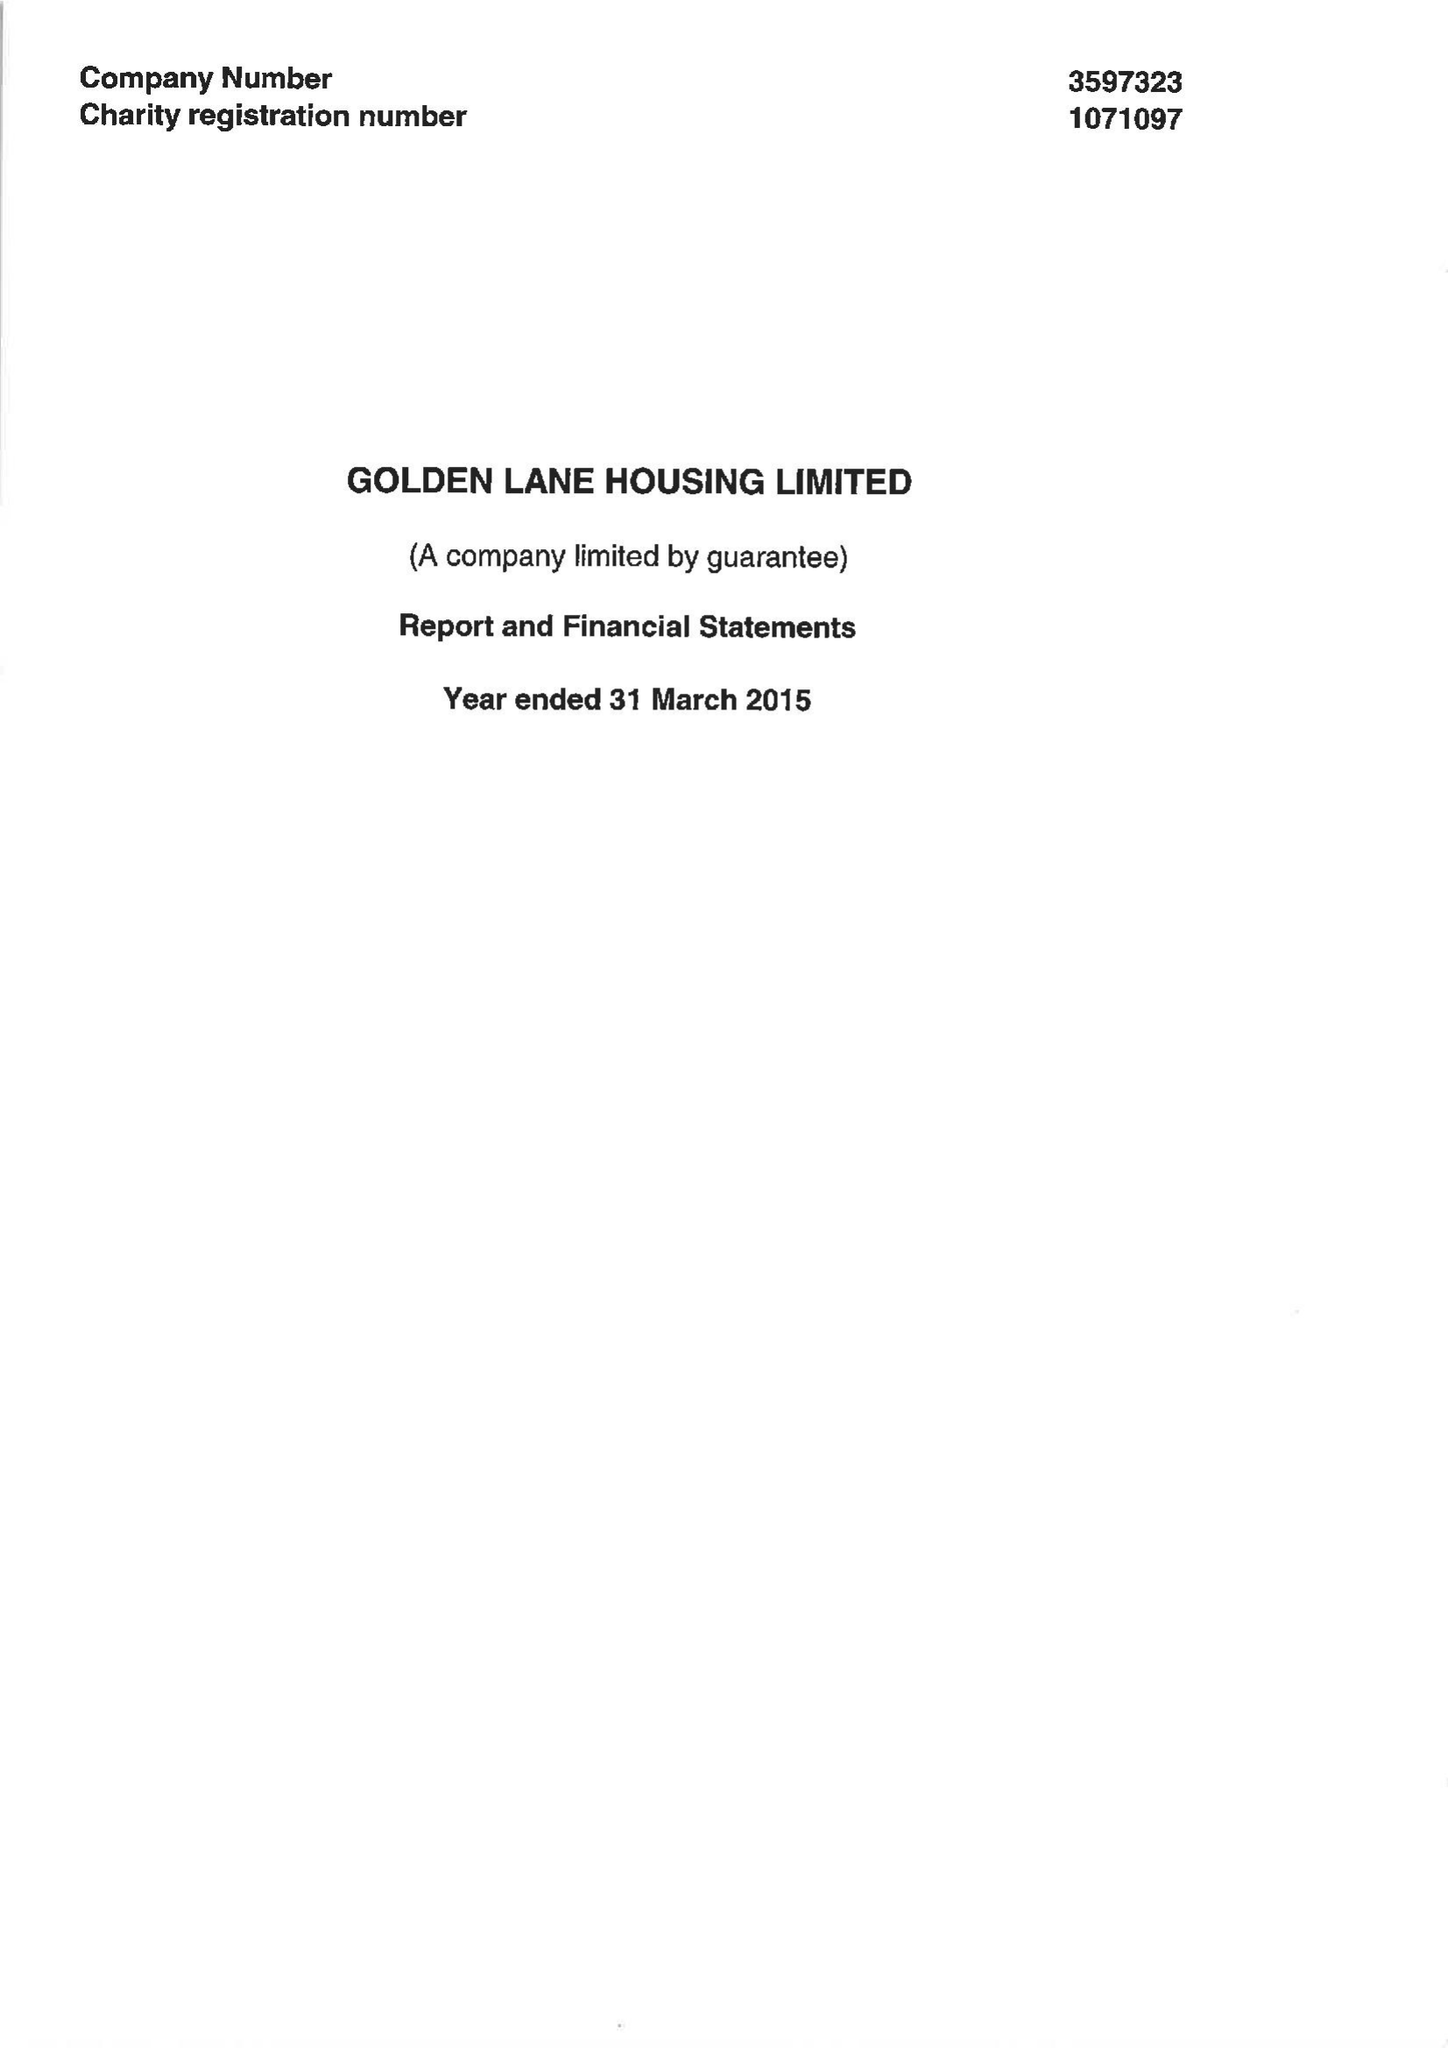What is the value for the address__street_line?
Answer the question using a single word or phrase. 123 GOLDEN LANE 